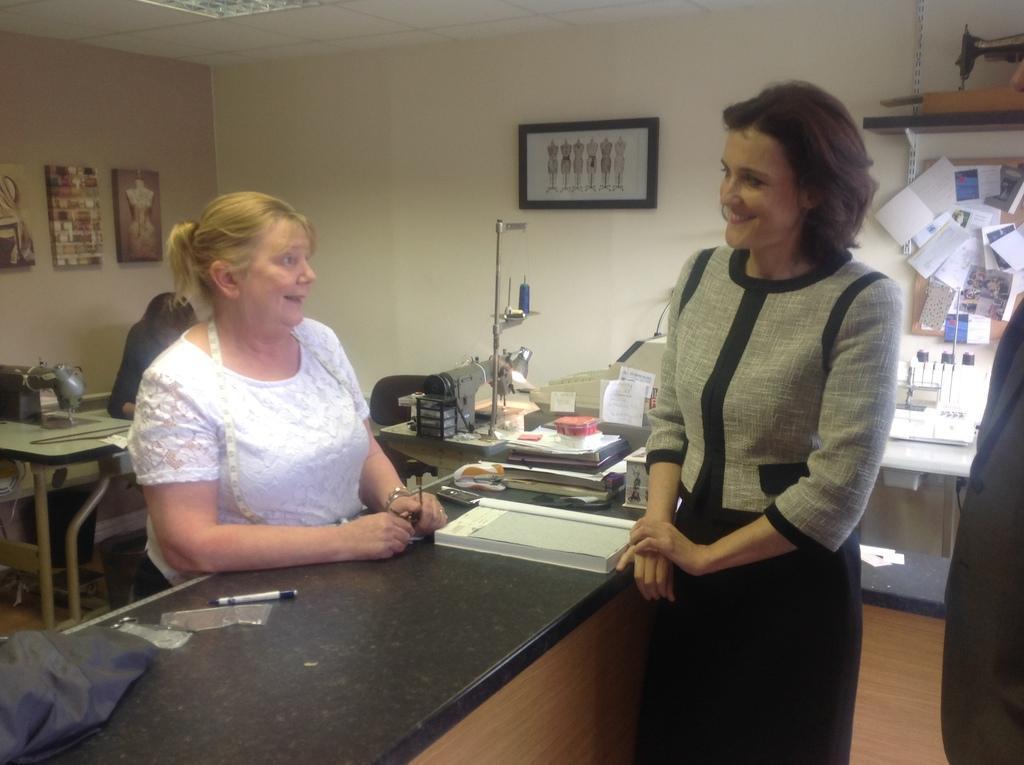How would you summarize this image in a sentence or two? In this image, we can see papers, books, pens, sewing machines and some other objects are on the tables. In the background, we can see some people and one of them is wearing a tailor meter and we can see frames are placed on the wall and there are papers and we can see a board. At the bottom, there is a floor. 